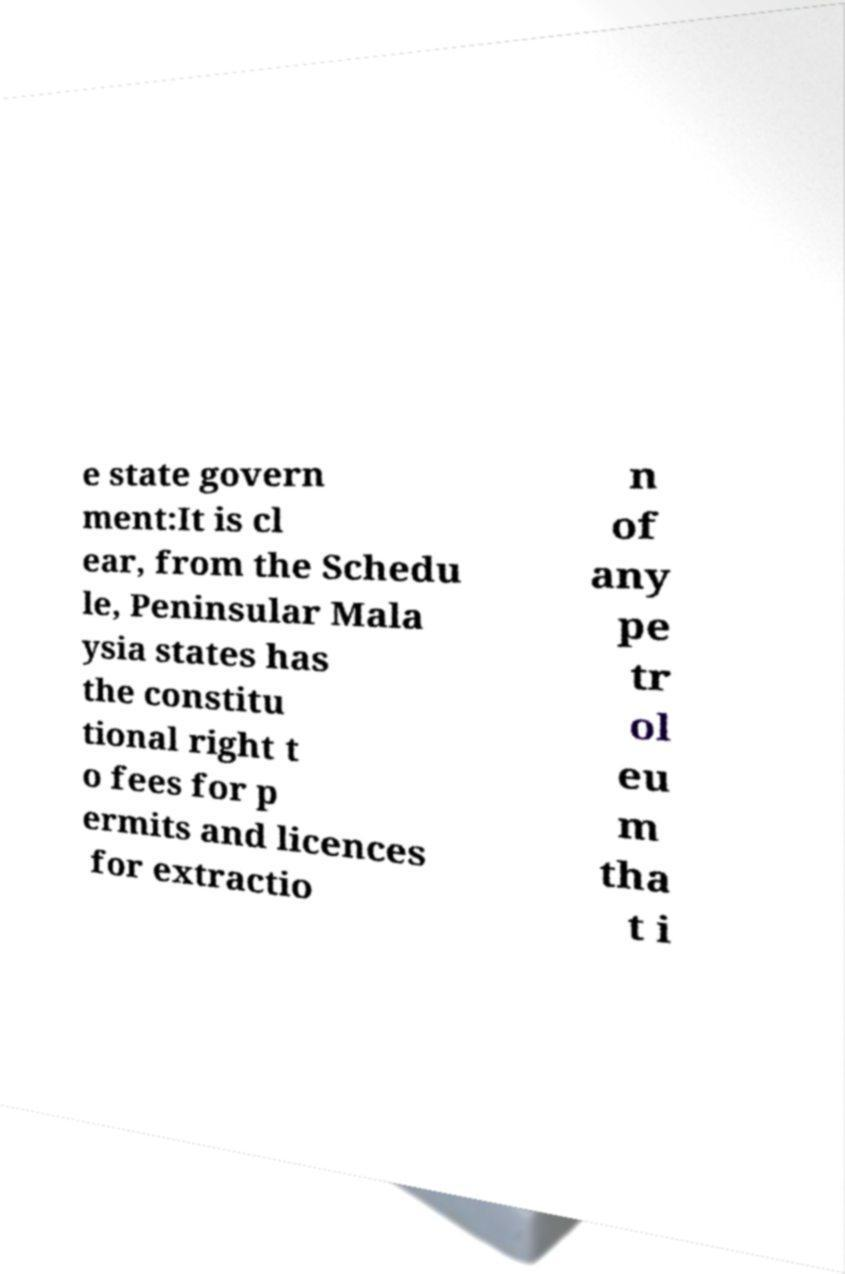Could you assist in decoding the text presented in this image and type it out clearly? e state govern ment:It is cl ear, from the Schedu le, Peninsular Mala ysia states has the constitu tional right t o fees for p ermits and licences for extractio n of any pe tr ol eu m tha t i 